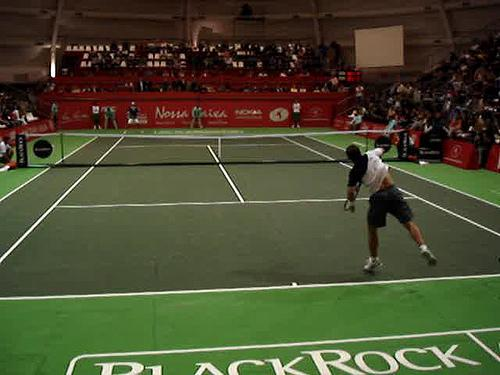What type of tennis swing is the main on the bottom of the court in the middle of? Please explain your reasoning. serve. The tennis swing is a serve. 